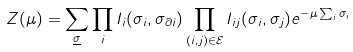<formula> <loc_0><loc_0><loc_500><loc_500>Z ( \mu ) = \sum _ { \underline { \sigma } } \prod _ { i } I _ { i } ( \sigma _ { i } , \sigma _ { \partial i } ) \prod _ { ( i , j ) \in \mathcal { E } } I _ { i j } ( \sigma _ { i } , \sigma _ { j } ) e ^ { - \mu \sum _ { i } \sigma _ { i } }</formula> 